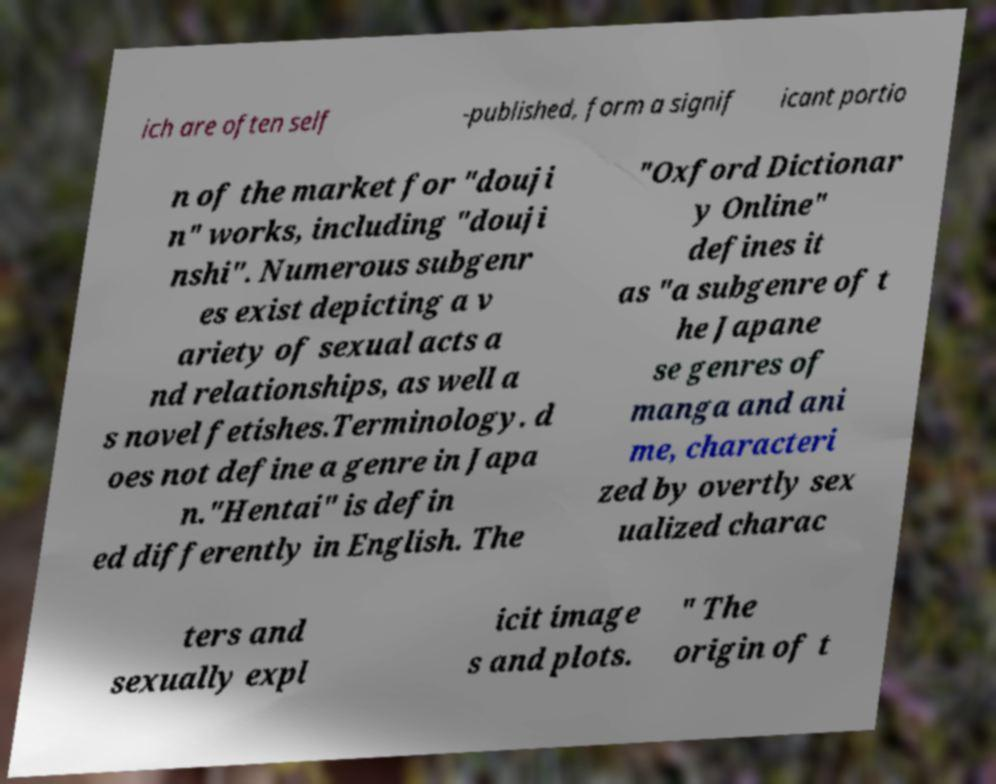Can you read and provide the text displayed in the image?This photo seems to have some interesting text. Can you extract and type it out for me? ich are often self -published, form a signif icant portio n of the market for "douji n" works, including "douji nshi". Numerous subgenr es exist depicting a v ariety of sexual acts a nd relationships, as well a s novel fetishes.Terminology. d oes not define a genre in Japa n."Hentai" is defin ed differently in English. The "Oxford Dictionar y Online" defines it as "a subgenre of t he Japane se genres of manga and ani me, characteri zed by overtly sex ualized charac ters and sexually expl icit image s and plots. " The origin of t 